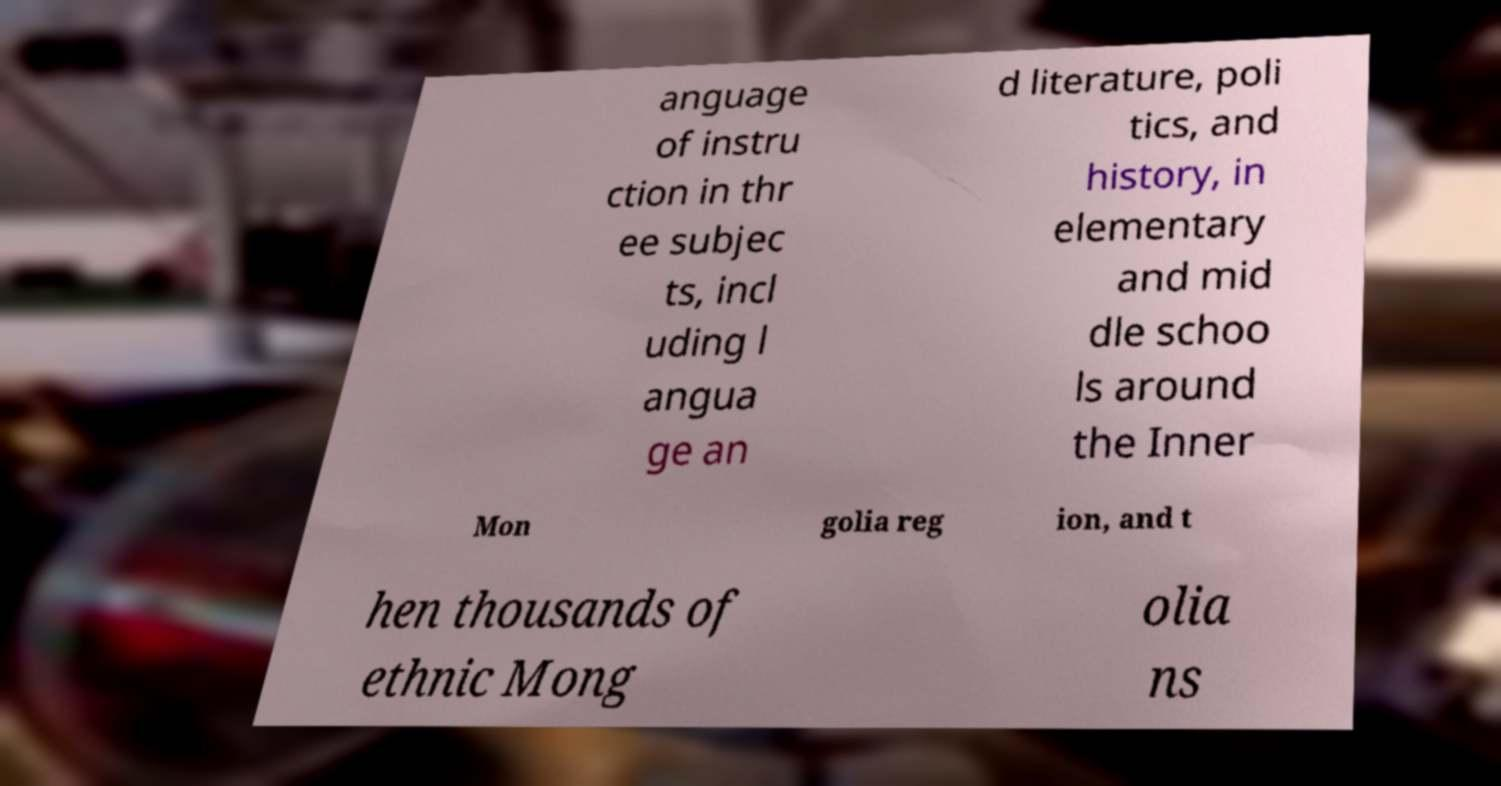Can you read and provide the text displayed in the image?This photo seems to have some interesting text. Can you extract and type it out for me? anguage of instru ction in thr ee subjec ts, incl uding l angua ge an d literature, poli tics, and history, in elementary and mid dle schoo ls around the Inner Mon golia reg ion, and t hen thousands of ethnic Mong olia ns 